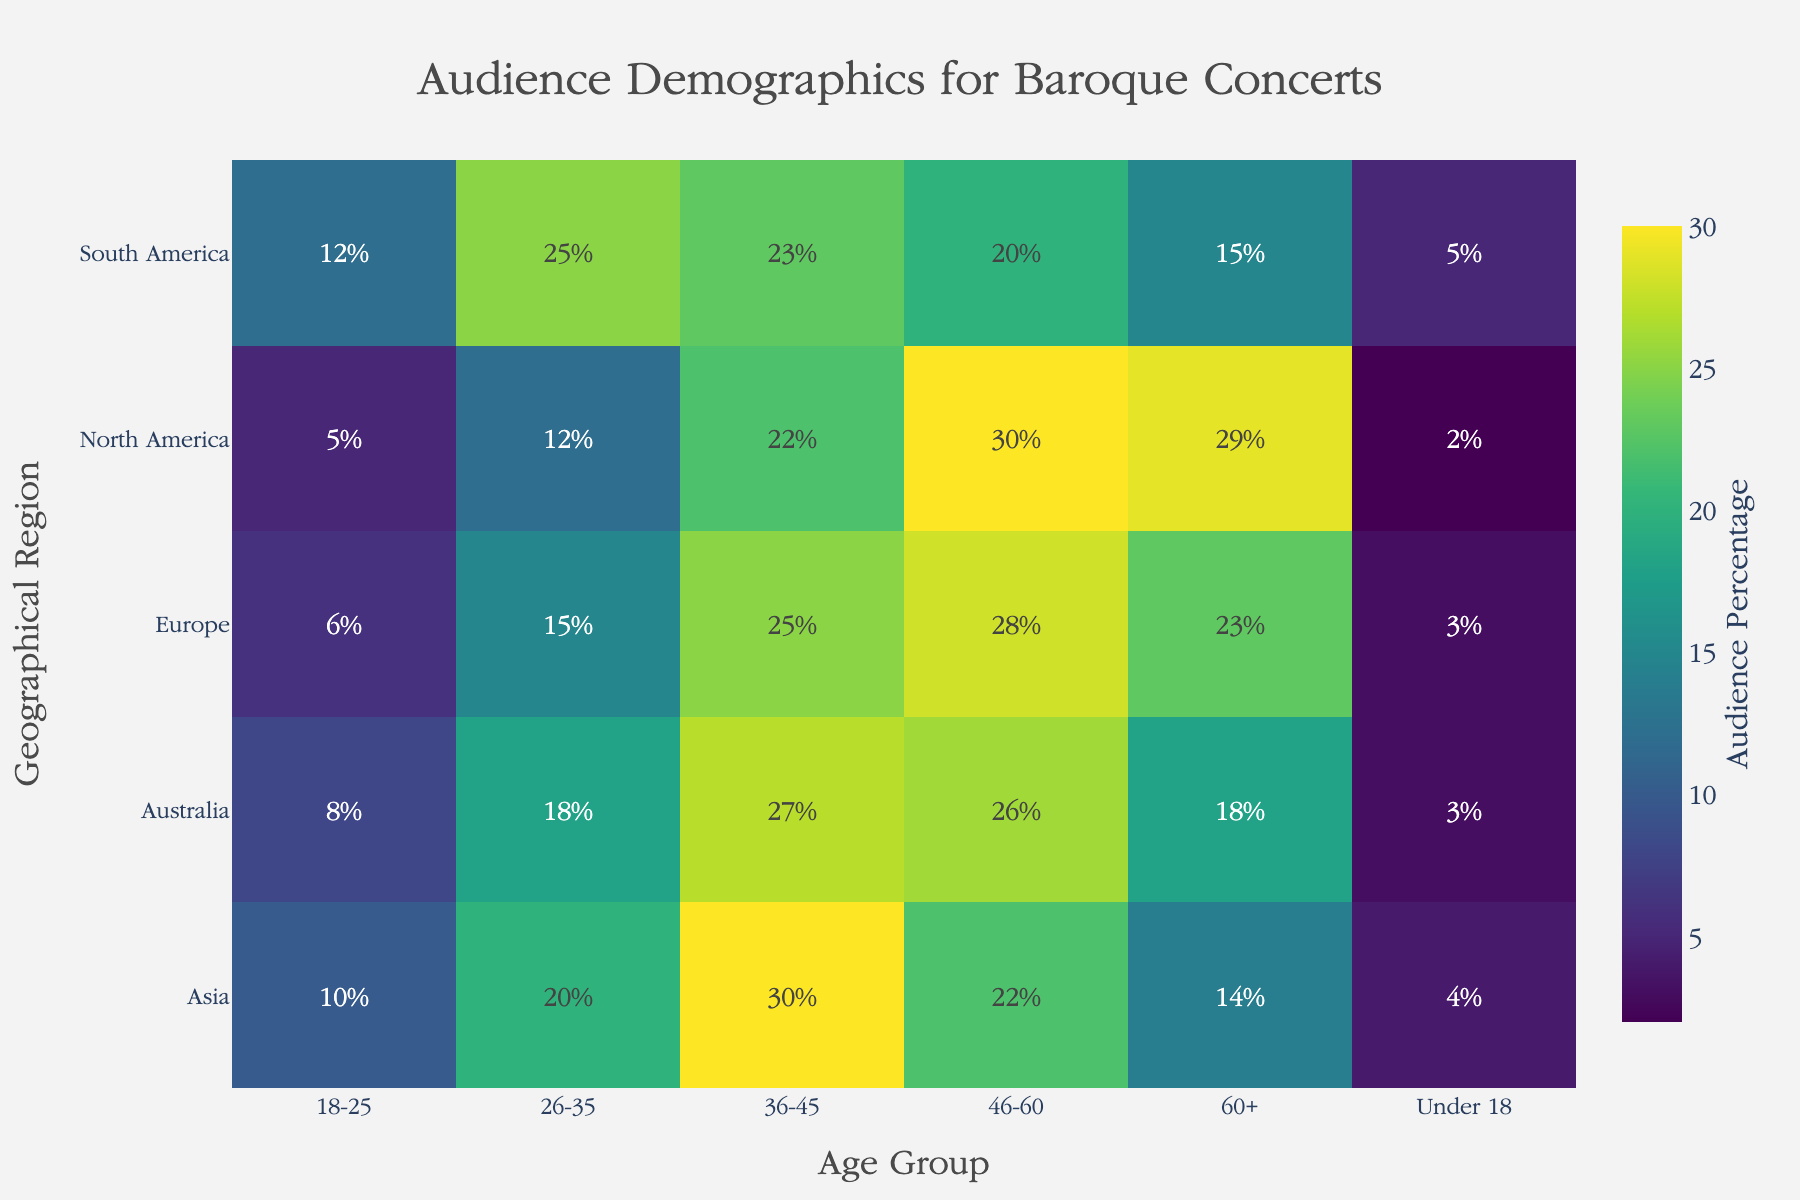What's the title of the heatmap? The figure includes a prominently placed title at the top, which provides an overall description of what the heatmap represents. The title is "Audience Demographics for Baroque Concerts".
Answer: Audience Demographics for Baroque Concerts Which geographical region has the highest percentage of audience from the "Under 18" age group? By visually scanning the heatmap's "Under 18" column, the cell with the highest value under this column is situated in the "South America" row. The value is 5%.
Answer: South America What age group has the highest audience percentage in Europe? Examine the row corresponding to "Europe" and compare the percentages across different age groups. The highest percentage in the Europe row is under the "36-45" age group, which is 25%.
Answer: 36-45 How does the audience percentage of the "60+" age group in Asia compare to that in North America? Compare the "60+" columns in both the Asia row and the North America row. In Asia, the percentage is 14%, whereas in North America, it is 29%.
Answer: Asia has a lower percentage (14%) compared to North America (29%) Which age group shows the same audience percentage in both North America and Europe? Analyze the data to find the age group with matching values. The "Under 18" age group has 2% in North America and 3% in Europe. This is not a match. Continue comparing each group until identifying "36-45", which has matching values of 22% in North America and 25% in Europe. Note: No exact match was found upon a second review. Therefore, no age group matches perfectly.
Answer: None What's the total percentage of the audience for the 26-35 age group across all regions? Sum the percentages for the 26-35 age group across North America (12%), Europe (15%), Asia (20%), South America (25%), and Australia (18%). Calculation: 12 + 15 + 20 + 25 + 18 = 90%.
Answer: 90% Which region has the lowest overall audience percentage for the "18-25" age group? By comparing cells within the "18-25" age group across all regions, the "North America" row shows the lowest percentage at 5%.
Answer: North America What is the difference in audience percentage between the "46-60" and "60+" age groups in Australia? Examine the percentages for these two age groups in Australia. For "46-60," it is 26%, and for "60+," it is 18%. The difference is calculated as 26 - 18 = 8%.
Answer: 8% How does the overall distribution of age groups differ between Europe and South America? Compare the full set of audience percentages across all age groups between Europe and South America. Notably, South America has higher percentages in the younger adult categories (18-25 and 26-35) compared to Europe, whereas Europe has a higher percentage in the older groups, notably "60+" with 23% compared to South America's lower 15%.
Answer: South America is higher in younger age groups, Europe higher in older age groups Which age group in North America has the highest deviation from its corresponding value in South America? By calculating the absolute difference for each age group between North America and South America: Under 18 (3%), 18-25 (7%), 26-35 (13%), 36-45 (1%), 46-60 (10%), and 60+ (14%). The age group with the highest difference is "26-35" with a 13% deviation.
Answer: 26-35 